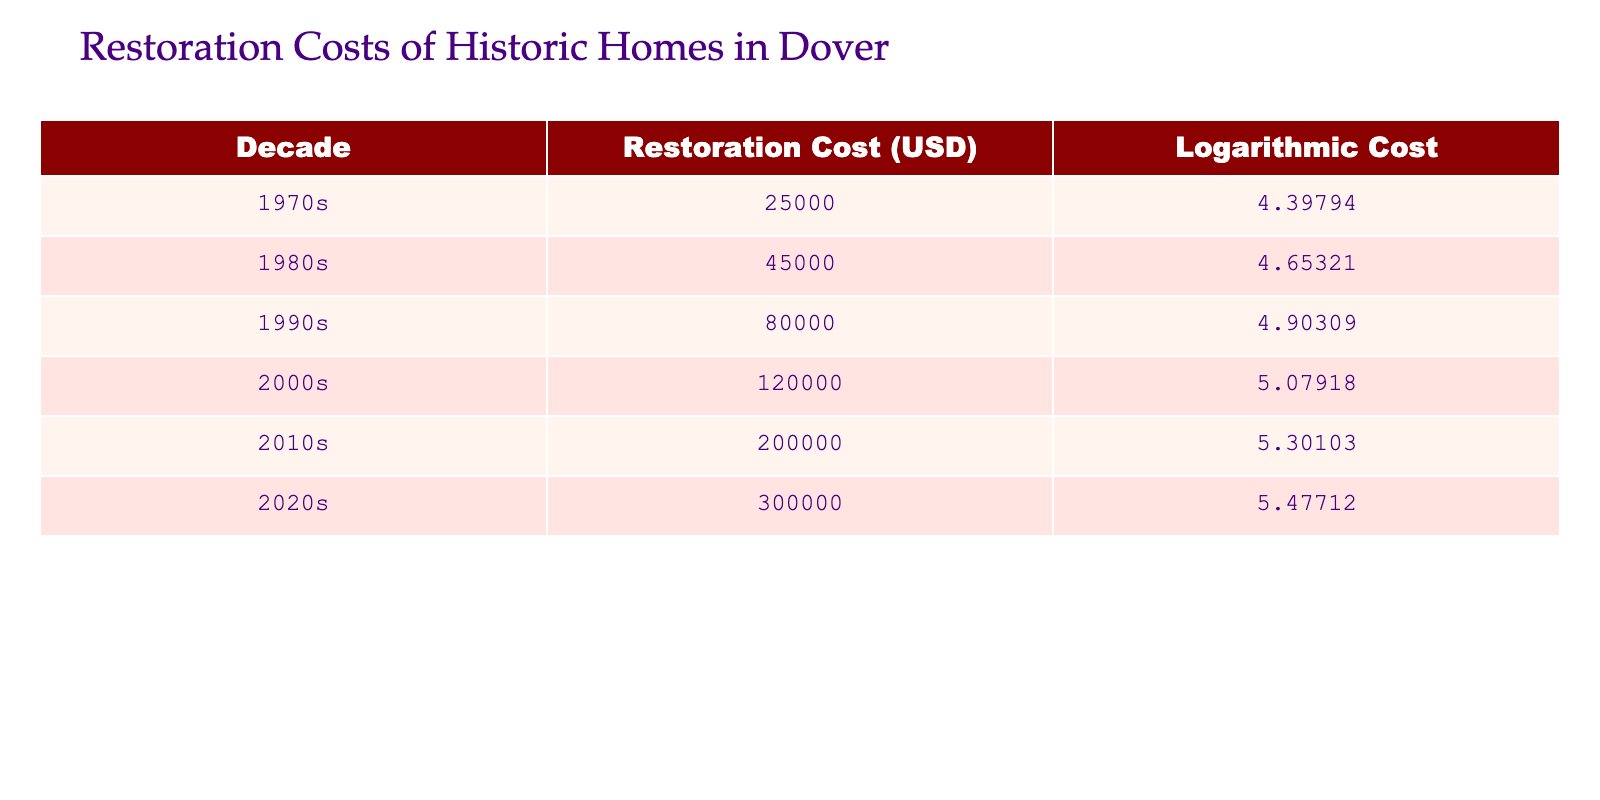What was the restoration cost in the 1980s? The table lists the restoration cost for the 1980s as 45000 USD.
Answer: 45000 USD Which decade had the highest restoration cost? By comparing the restoration costs across the decades, the 2020s have the highest restoration cost listed at 300000 USD.
Answer: 2020s What is the average restoration cost for the 1990s and 2000s combined? To find the average, first add the restoration costs for the 1990s (80000 USD) and 2000s (120000 USD), which equals 200000 USD. Then divide by 2, resulting in an average of 100000 USD.
Answer: 100000 USD Is the restoration cost in the 1970s higher than that in the 1980s? The restoration cost in the 1970s is 25000 USD, while in the 1980s it is 45000 USD. Since 25000 is less than 45000, the statement is false.
Answer: No What is the difference in restoration costs between the 2010s and the 2000s? The restoration cost for the 2010s is 200000 USD and for the 2000s it is 120000 USD. The difference is calculated by subtracting the 2000s cost from the 2010s cost: 200000 - 120000 = 80000 USD.
Answer: 80000 USD How much did the restoration costs increase from the 1990s to the 2020s? The restoration cost in the 1990s is 80000 USD and in the 2020s is 300000 USD. To find the increase, subtract the 1990s cost from the 2020s cost: 300000 - 80000 = 220000 USD.
Answer: 220000 USD Is the logarithmic cost for the 2000s greater than for the 1980s? The logarithmic cost for the 2000s is 5.07918 and for the 1980s is 4.65321. Since 5.07918 is greater than 4.65321, this statement is true.
Answer: Yes What is the total restoration cost for all decades combined? Adding the restoration costs for all decades: 25000 + 45000 + 80000 + 120000 + 200000 + 300000 = 1000000 USD.
Answer: 1000000 USD What is the ratio of restoration costs between the 2020s and the 1970s? The restoration cost in the 2020s is 300000 USD and in the 1970s is 25000 USD. To find the ratio, divide the 2020s cost by the 1970s cost: 300000 / 25000 = 12. This means the restoration cost in the 2020s is 12 times that in the 1970s.
Answer: 12 